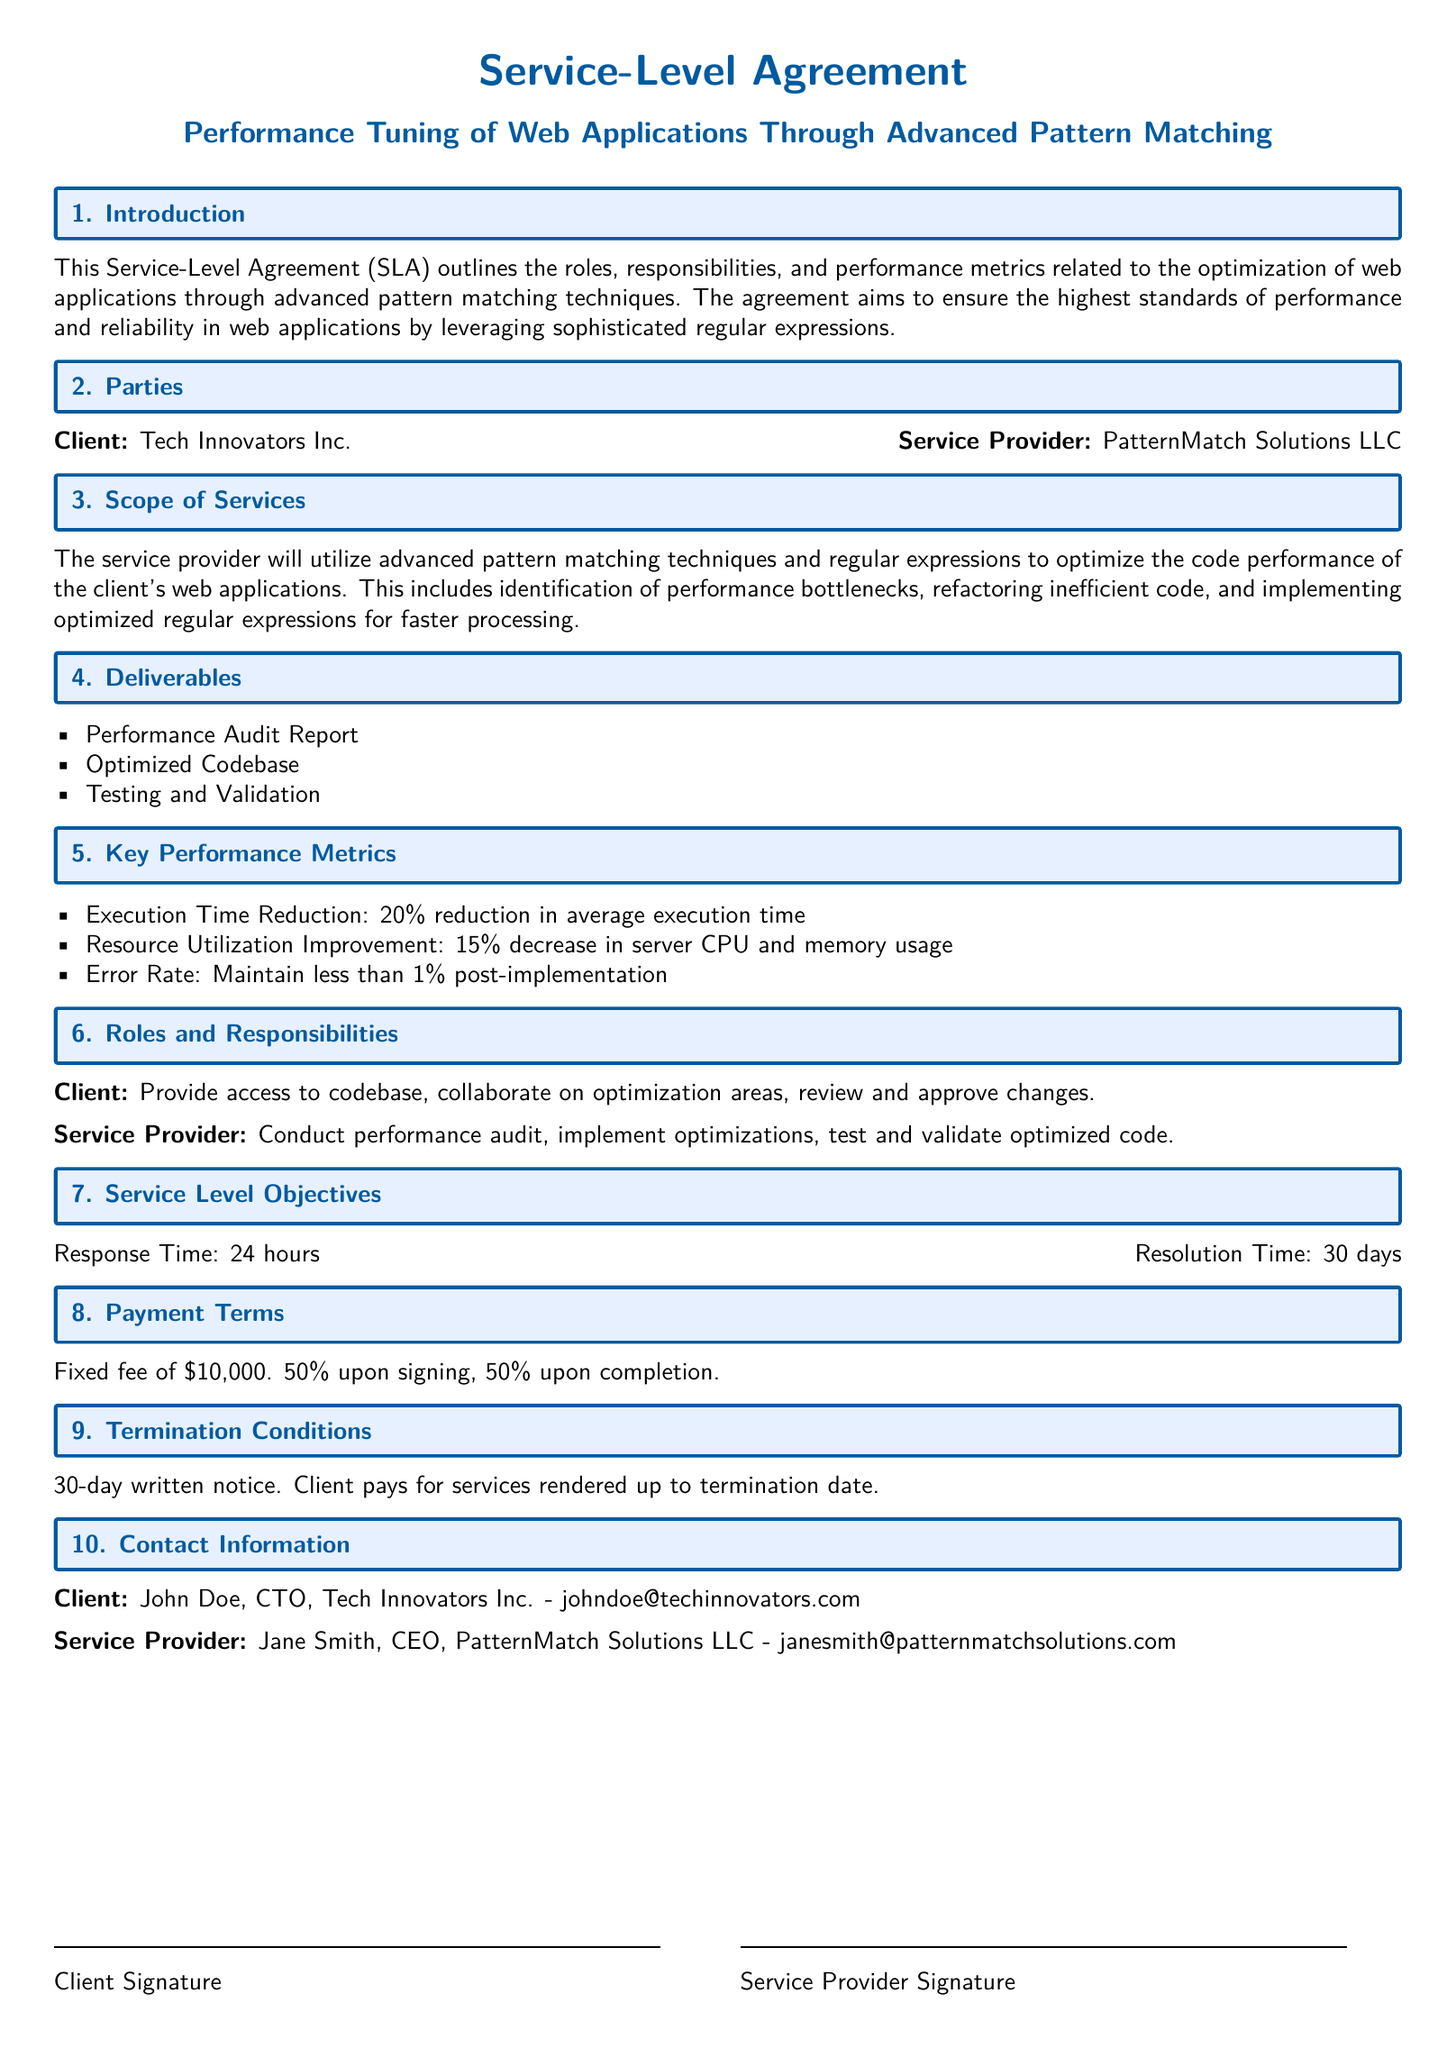what is the name of the client? The document specifies the client as Tech Innovators Inc.
Answer: Tech Innovators Inc who is the CEO of the service provider? The document lists Jane Smith as the CEO of PatternMatch Solutions LLC.
Answer: Jane Smith how much is the fixed fee for the service? The payment terms indicate a fixed fee of ten thousand dollars.
Answer: $10,000 what is the execution time reduction goal? The key performance metrics state a 20% reduction in average execution time.
Answer: 20% how long is the resolution time stated in the SLA? The service level objectives indicate a resolution time of thirty days.
Answer: 30 days what is the error rate maintenance goal? The document sets a goal to maintain less than 1% post-implementation error rate.
Answer: less than 1% what is the role of the client regarding the codebase? The client's responsibility is to provide access to the codebase.
Answer: Provide access to codebase what is included in the deliverables? The deliverables include a performance audit report, optimized codebase, and testing and validation.
Answer: Performance Audit Report, Optimized Codebase, Testing and Validation what is the response time required in the SLA? The service level objectives specify a response time of twenty-four hours.
Answer: 24 hours 